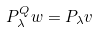<formula> <loc_0><loc_0><loc_500><loc_500>P _ { \lambda } ^ { Q } w = P _ { \lambda } v</formula> 